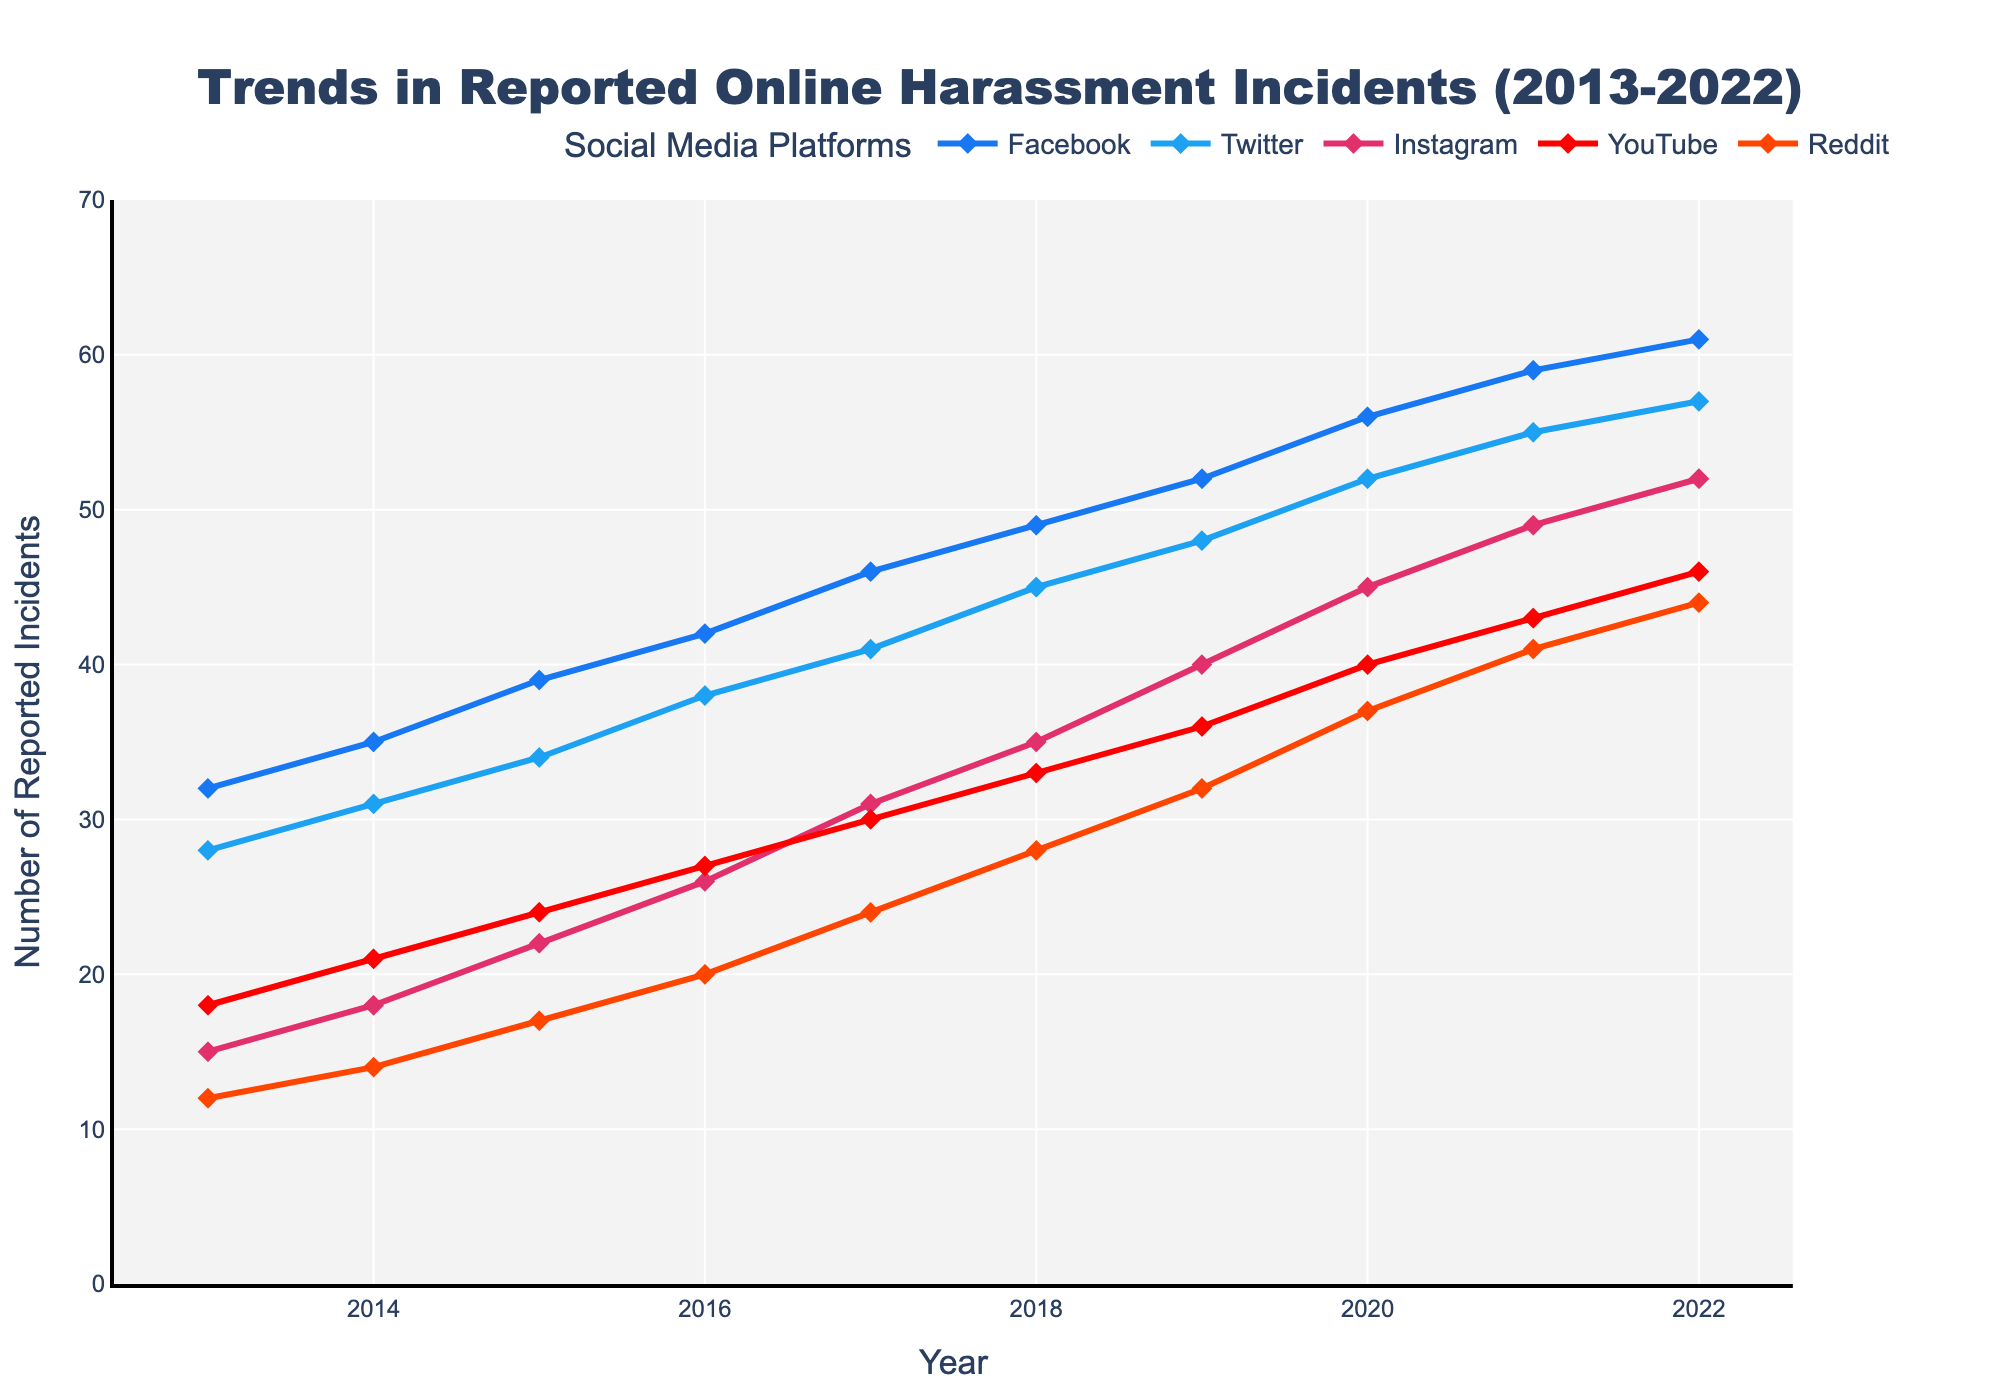Which platform saw the most significant increase in reported online harassment incidents from 2013 to 2022? Comparing the initial and final values for each platform: Facebook (61-32=29), Twitter (57-28=29), Instagram (52-15=37), YouTube (46-18=28), Reddit (44-12=32). Instagram had the highest increase of 37.
Answer: Instagram What year did Twitter have 31 reported incidents? Based on the figure, Twitter had 31 reported incidents in 2014.
Answer: 2014 Which platform had fewer reported incidents in 2022 compared to YouTube in 2018 and by how many? YouTube in 2018 had 33 incidents. In 2022, Twitter had 57, Facebook had 61, Instagram had 52, YouTube had 46, and Reddit had 44. No platform had fewer incidents than YouTube in 2018 in 2022.
Answer: None Compare the increase in reported incidents for Facebook and Reddit between 2013 and 2017. Which one had a larger increase? Facebook: 46-32=14. Reddit: 24-12=12. Facebook saw a larger increase than Reddit.
Answer: Facebook What is the average number of reported incidents on Instagram over the entire decade? Summing up the incidents: 15+18+22+26+31+35+40+45+49+52 = 333. Dividing by 10 years: 333/10 = 33.3.
Answer: 33.3 In which year did all platforms except Instagram see a collective surpassing of 120 reported incidents? In 2015, Facebook (39), Twitter (34), YouTube (24), and Reddit (17) collectively had 39+34+24+17=114 incidents. In 2016, they had 42+38+27+20=127 incidents. Thus, 2016 is the year they collectively surpassed 120 incidents.
Answer: 2016 Which platform had the smallest increase in reported incidents from 2013 to 2016? Calculating the increases: Facebook 42-32=10, Twitter 38-28=10, Instagram 26-15=11, YouTube 27-18=9, Reddit 20-12=8. Reddit had the smallest increase of 8.
Answer: Reddit How many more incidents were reported on Facebook than on Twitter in 2020? Facebook had 56 incidents and Twitter had 52 in 2020. The difference is 56-52 = 4 incidents.
Answer: 4 How did the reported incidents on Reddit change between 2015 and 2022? In 2015, Reddit had 17 incidents, and in 2022, there were 44 incidents. The change is 44-17=27.
Answer: Increased by 27 